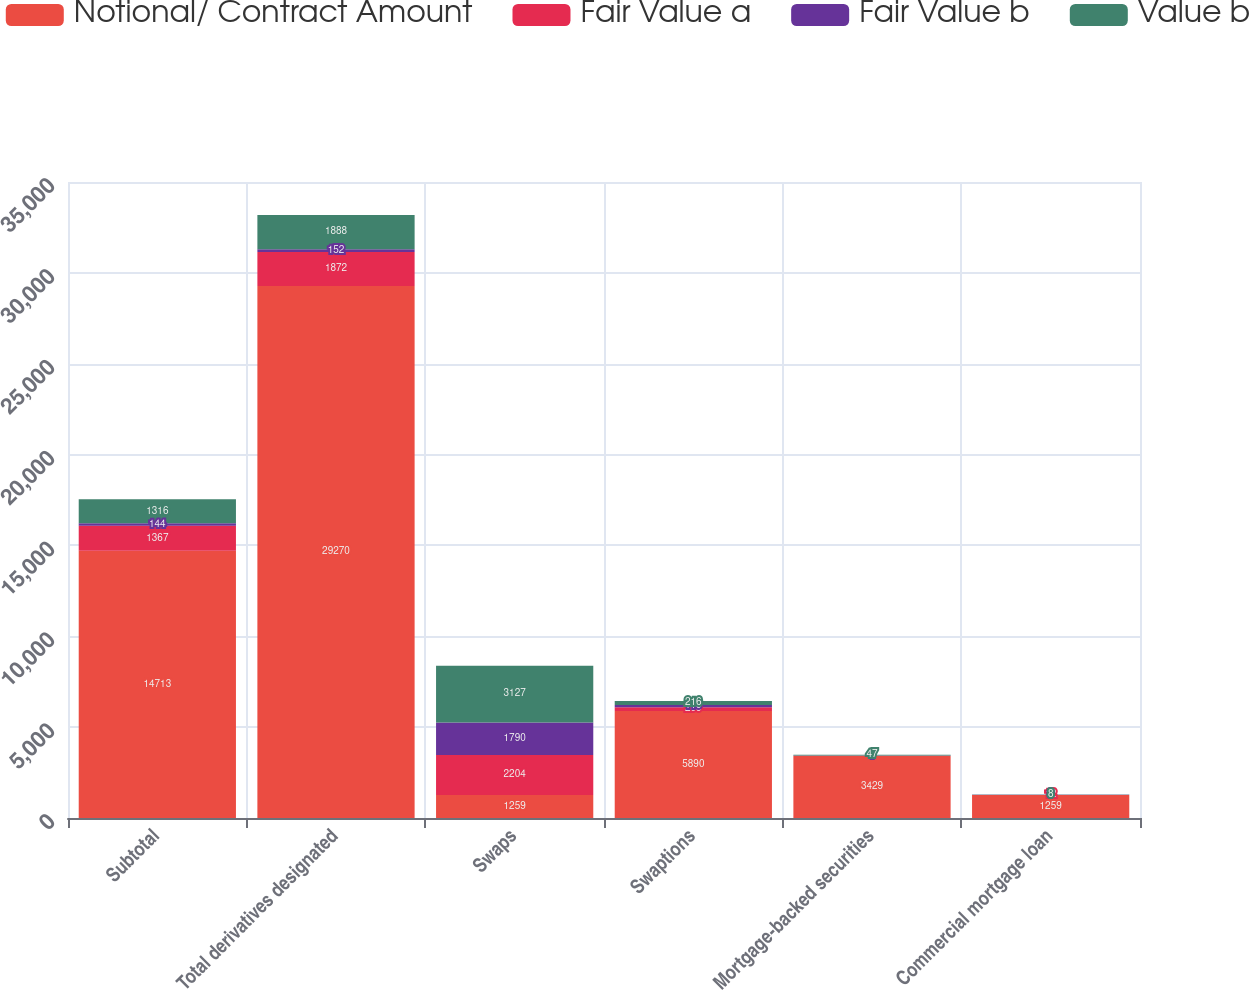<chart> <loc_0><loc_0><loc_500><loc_500><stacked_bar_chart><ecel><fcel>Subtotal<fcel>Total derivatives designated<fcel>Swaps<fcel>Swaptions<fcel>Mortgage-backed securities<fcel>Commercial mortgage loan<nl><fcel>Notional/ Contract Amount<fcel>14713<fcel>29270<fcel>1259<fcel>5890<fcel>3429<fcel>1259<nl><fcel>Fair Value a<fcel>1367<fcel>1872<fcel>2204<fcel>209<fcel>3<fcel>12<nl><fcel>Fair Value b<fcel>144<fcel>152<fcel>1790<fcel>119<fcel>1<fcel>9<nl><fcel>Value b<fcel>1316<fcel>1888<fcel>3127<fcel>216<fcel>47<fcel>8<nl></chart> 